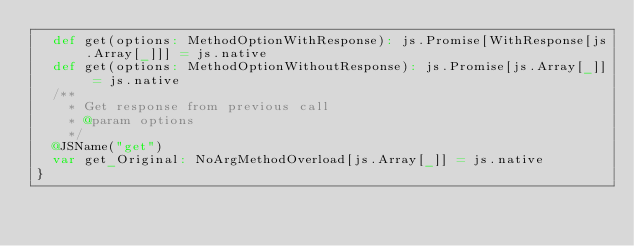Convert code to text. <code><loc_0><loc_0><loc_500><loc_500><_Scala_>  def get(options: MethodOptionWithResponse): js.Promise[WithResponse[js.Array[_]]] = js.native
  def get(options: MethodOptionWithoutResponse): js.Promise[js.Array[_]] = js.native
  /**
    * Get response from previous call
    * @param options
    */
  @JSName("get")
  var get_Original: NoArgMethodOverload[js.Array[_]] = js.native
}
</code> 